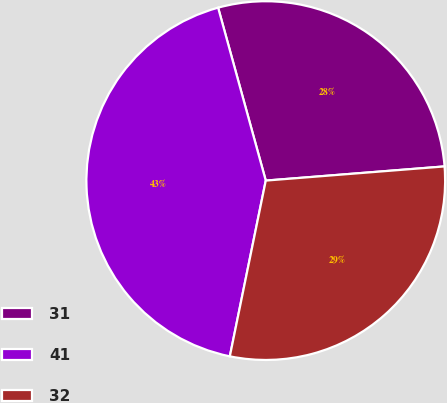<chart> <loc_0><loc_0><loc_500><loc_500><pie_chart><fcel>31<fcel>41<fcel>32<nl><fcel>28.02%<fcel>42.51%<fcel>29.47%<nl></chart> 